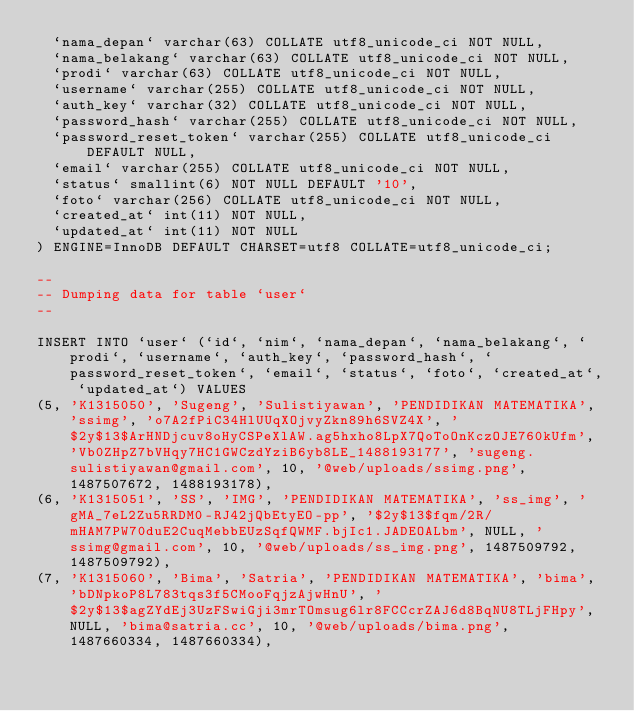<code> <loc_0><loc_0><loc_500><loc_500><_SQL_>  `nama_depan` varchar(63) COLLATE utf8_unicode_ci NOT NULL,
  `nama_belakang` varchar(63) COLLATE utf8_unicode_ci NOT NULL,
  `prodi` varchar(63) COLLATE utf8_unicode_ci NOT NULL,
  `username` varchar(255) COLLATE utf8_unicode_ci NOT NULL,
  `auth_key` varchar(32) COLLATE utf8_unicode_ci NOT NULL,
  `password_hash` varchar(255) COLLATE utf8_unicode_ci NOT NULL,
  `password_reset_token` varchar(255) COLLATE utf8_unicode_ci DEFAULT NULL,
  `email` varchar(255) COLLATE utf8_unicode_ci NOT NULL,
  `status` smallint(6) NOT NULL DEFAULT '10',
  `foto` varchar(256) COLLATE utf8_unicode_ci NOT NULL,
  `created_at` int(11) NOT NULL,
  `updated_at` int(11) NOT NULL
) ENGINE=InnoDB DEFAULT CHARSET=utf8 COLLATE=utf8_unicode_ci;

--
-- Dumping data for table `user`
--

INSERT INTO `user` (`id`, `nim`, `nama_depan`, `nama_belakang`, `prodi`, `username`, `auth_key`, `password_hash`, `password_reset_token`, `email`, `status`, `foto`, `created_at`, `updated_at`) VALUES
(5, 'K1315050', 'Sugeng', 'Sulistiyawan', 'PENDIDIKAN MATEMATIKA', 'ssimg', 'o7A2fPiC34HlUUqXOjvyZkn89h6SVZ4X', '$2y$13$ArHNDjcuv8oHyCSPeXlAW.ag5hxho8LpX7QoToOnKczOJE760kUfm', 'Vb0ZHpZ7bVHqy7HC1GWCzdYziB6yb8LE_1488193177', 'sugeng.sulistiyawan@gmail.com', 10, '@web/uploads/ssimg.png', 1487507672, 1488193178),
(6, 'K1315051', 'SS', 'IMG', 'PENDIDIKAN MATEMATIKA', 'ss_img', 'gMA_7eL2Zu5RRDM0-RJ42jQbEtyEO-pp', '$2y$13$fqm/2R/mHAM7PW70duE2CuqMebbEUzSqfQWMF.bjIc1.JADEOALbm', NULL, 'ssimg@gmail.com', 10, '@web/uploads/ss_img.png', 1487509792, 1487509792),
(7, 'K1315060', 'Bima', 'Satria', 'PENDIDIKAN MATEMATIKA', 'bima', 'bDNpkoP8L783tqs3f5CMooFqjzAjwHnU', '$2y$13$agZYdEj3UzFSwiGji3mrTOmsug6lr8FCCcrZAJ6d8BqNU8TLjFHpy', NULL, 'bima@satria.cc', 10, '@web/uploads/bima.png', 1487660334, 1487660334),</code> 